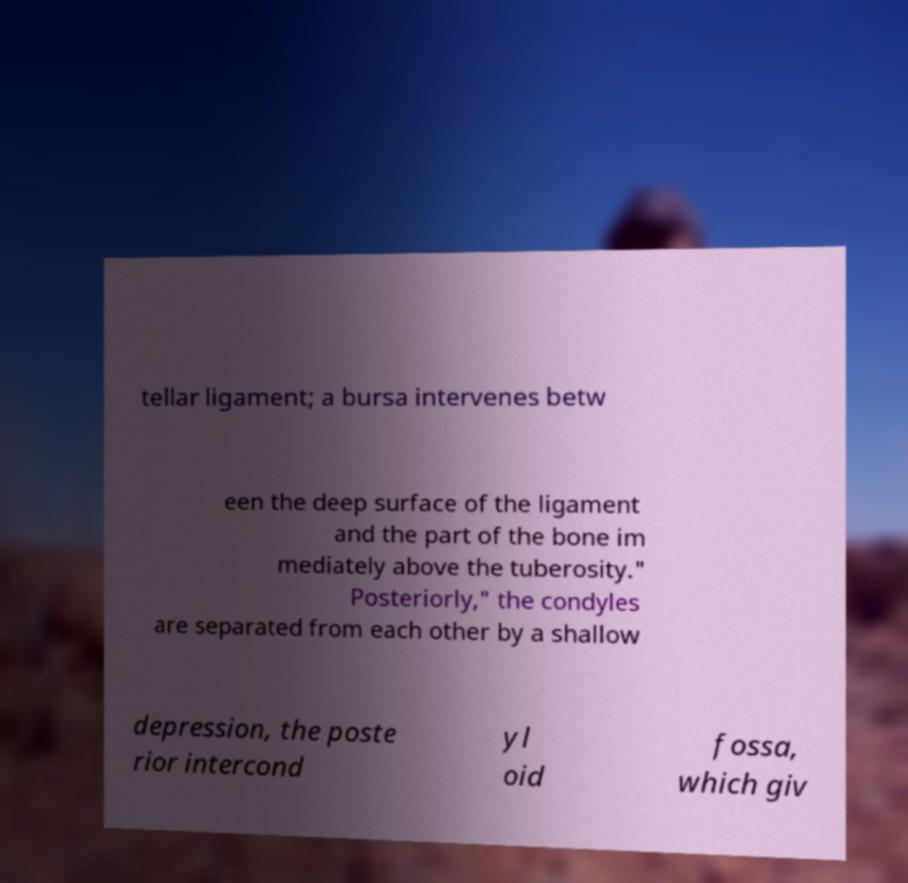There's text embedded in this image that I need extracted. Can you transcribe it verbatim? tellar ligament; a bursa intervenes betw een the deep surface of the ligament and the part of the bone im mediately above the tuberosity." Posteriorly," the condyles are separated from each other by a shallow depression, the poste rior intercond yl oid fossa, which giv 